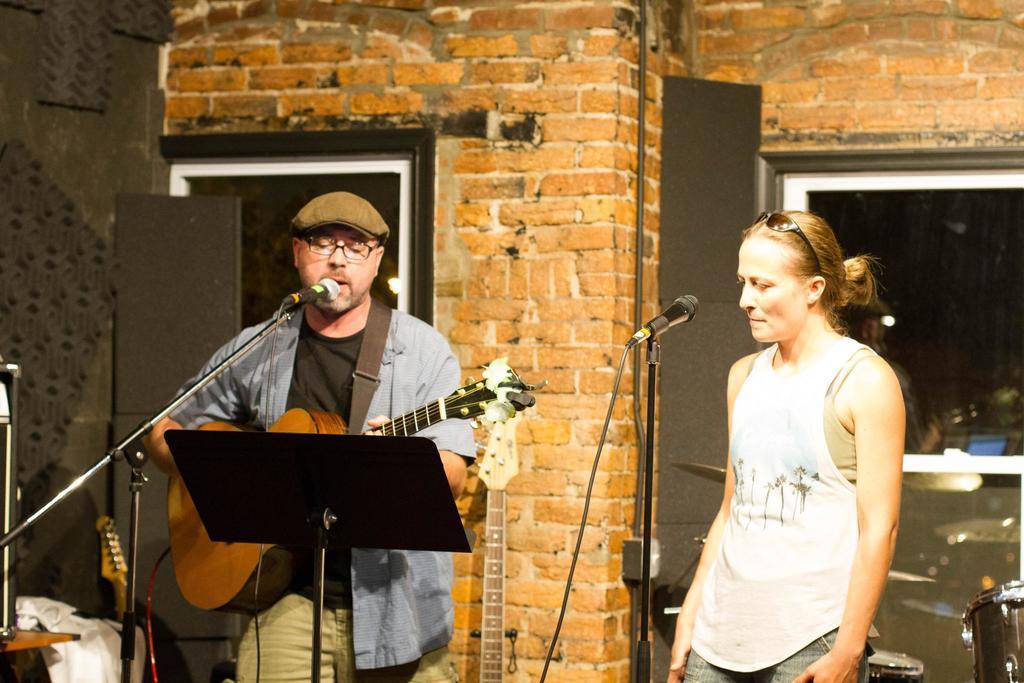Please provide a concise description of this image. In this image i can see a man and a woman, a man holding a guitar and playing and singing in front of a micro phone,at the back ground i can see a brick wall, a frame attached to a wall and a window. 